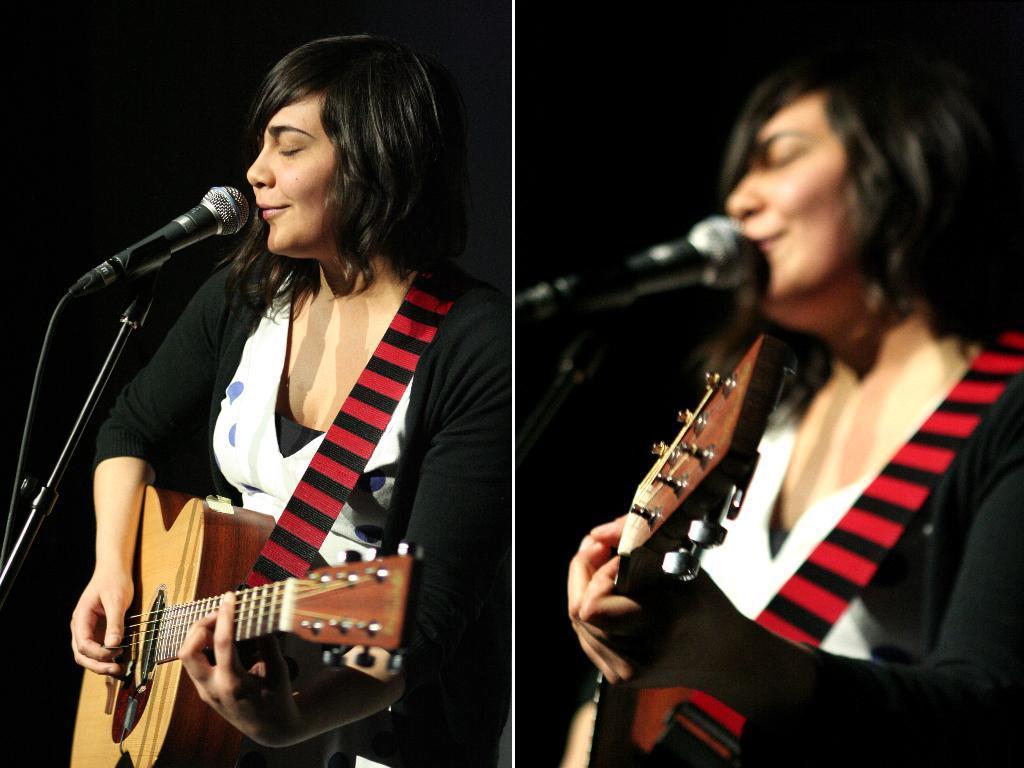How would you summarize this image in a sentence or two? The image is collage of two pictures. In both the images the person is same. One picture is clear and another picture is blurred. The woman is wearing a black shrug, white dress and holding a guitar. In front of her there is a mike. 